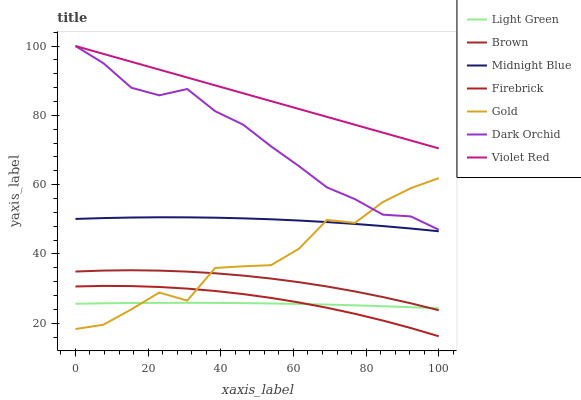Does Light Green have the minimum area under the curve?
Answer yes or no. Yes. Does Violet Red have the maximum area under the curve?
Answer yes or no. Yes. Does Midnight Blue have the minimum area under the curve?
Answer yes or no. No. Does Midnight Blue have the maximum area under the curve?
Answer yes or no. No. Is Violet Red the smoothest?
Answer yes or no. Yes. Is Gold the roughest?
Answer yes or no. Yes. Is Midnight Blue the smoothest?
Answer yes or no. No. Is Midnight Blue the roughest?
Answer yes or no. No. Does Midnight Blue have the lowest value?
Answer yes or no. No. Does Dark Orchid have the highest value?
Answer yes or no. Yes. Does Midnight Blue have the highest value?
Answer yes or no. No. Is Light Green less than Violet Red?
Answer yes or no. Yes. Is Violet Red greater than Midnight Blue?
Answer yes or no. Yes. Does Gold intersect Midnight Blue?
Answer yes or no. Yes. Is Gold less than Midnight Blue?
Answer yes or no. No. Is Gold greater than Midnight Blue?
Answer yes or no. No. Does Light Green intersect Violet Red?
Answer yes or no. No. 